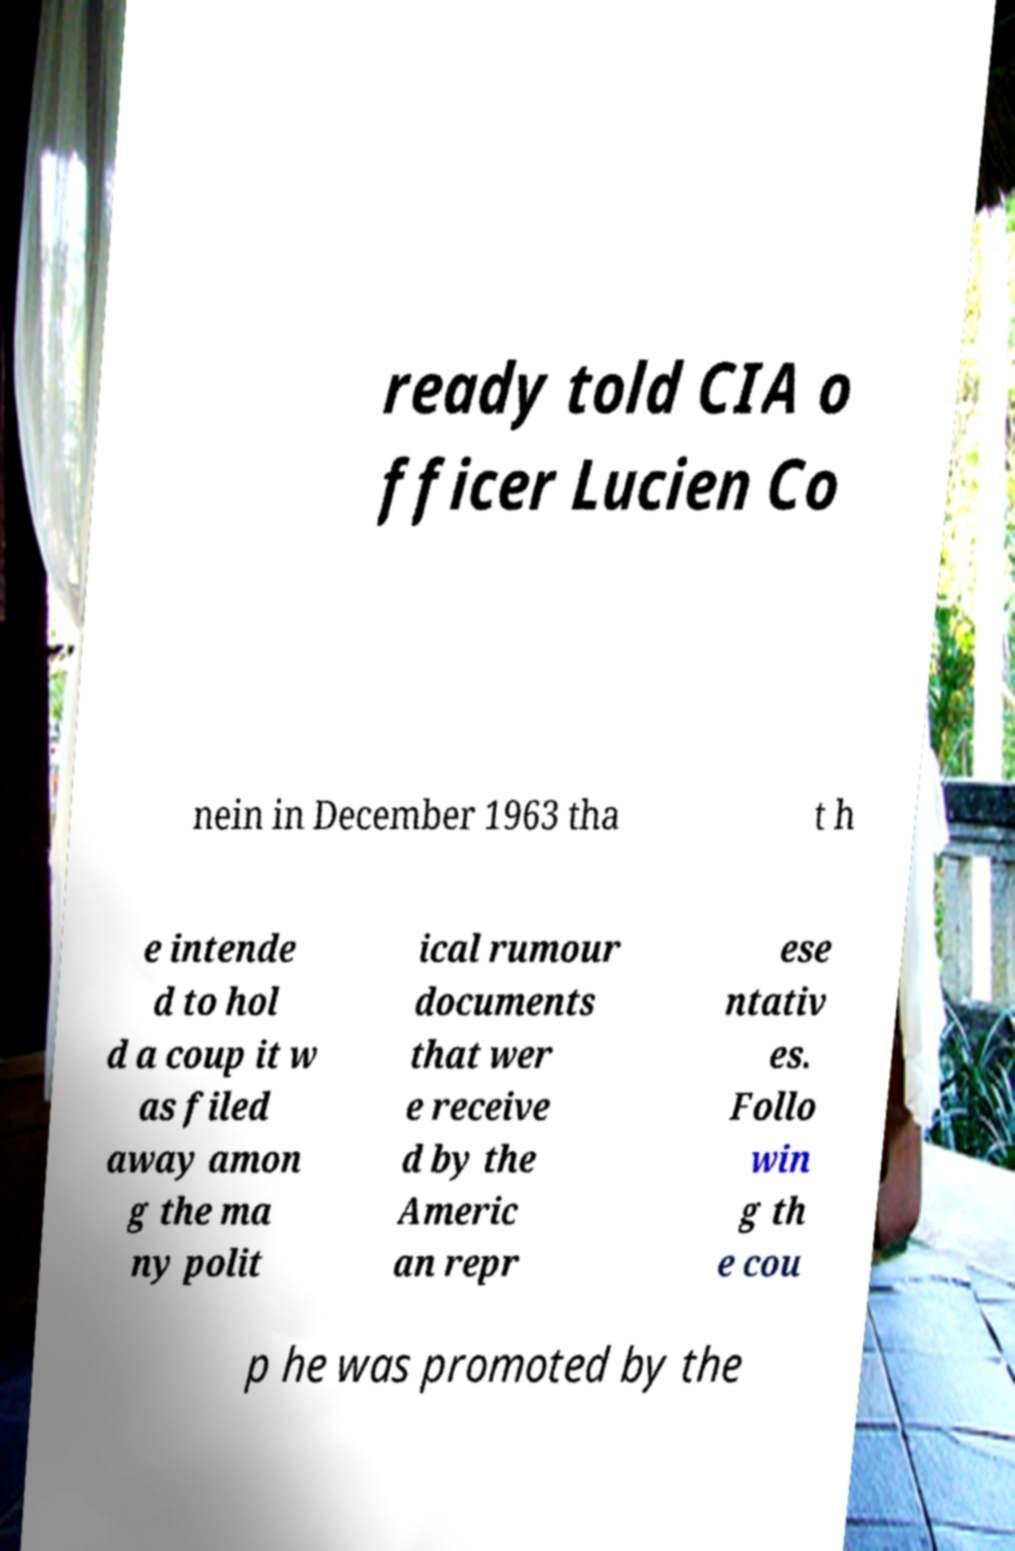Please read and relay the text visible in this image. What does it say? ready told CIA o fficer Lucien Co nein in December 1963 tha t h e intende d to hol d a coup it w as filed away amon g the ma ny polit ical rumour documents that wer e receive d by the Americ an repr ese ntativ es. Follo win g th e cou p he was promoted by the 